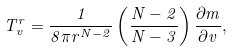<formula> <loc_0><loc_0><loc_500><loc_500>T ^ { r } _ { v } = \frac { 1 } { 8 \pi r ^ { N - 2 } } \left ( \frac { N - 2 } { N - 3 } \right ) \frac { \partial m } { \partial v } ,</formula> 